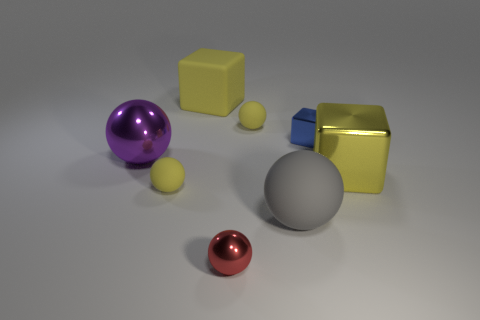Do the matte cube and the big shiny cube have the same color?
Provide a succinct answer. Yes. How big is the gray object?
Offer a terse response. Large. There is a large matte object in front of the tiny rubber sphere in front of the large shiny thing that is on the left side of the big gray sphere; what color is it?
Provide a succinct answer. Gray. There is a small matte ball left of the red ball; does it have the same color as the matte block?
Offer a terse response. Yes. How many shiny objects are both on the right side of the large yellow rubber thing and behind the gray object?
Offer a very short reply. 2. The red metallic thing that is the same shape as the gray rubber thing is what size?
Your answer should be compact. Small. There is a large yellow thing right of the gray object that is in front of the big matte block; what number of big matte objects are in front of it?
Provide a short and direct response. 1. What is the color of the big metallic thing that is left of the tiny rubber ball in front of the small shiny cube?
Offer a very short reply. Purple. What number of rubber things are right of the big rubber block that is behind the gray ball?
Provide a short and direct response. 2. Is there anything else that is the same shape as the yellow metallic object?
Your response must be concise. Yes. 